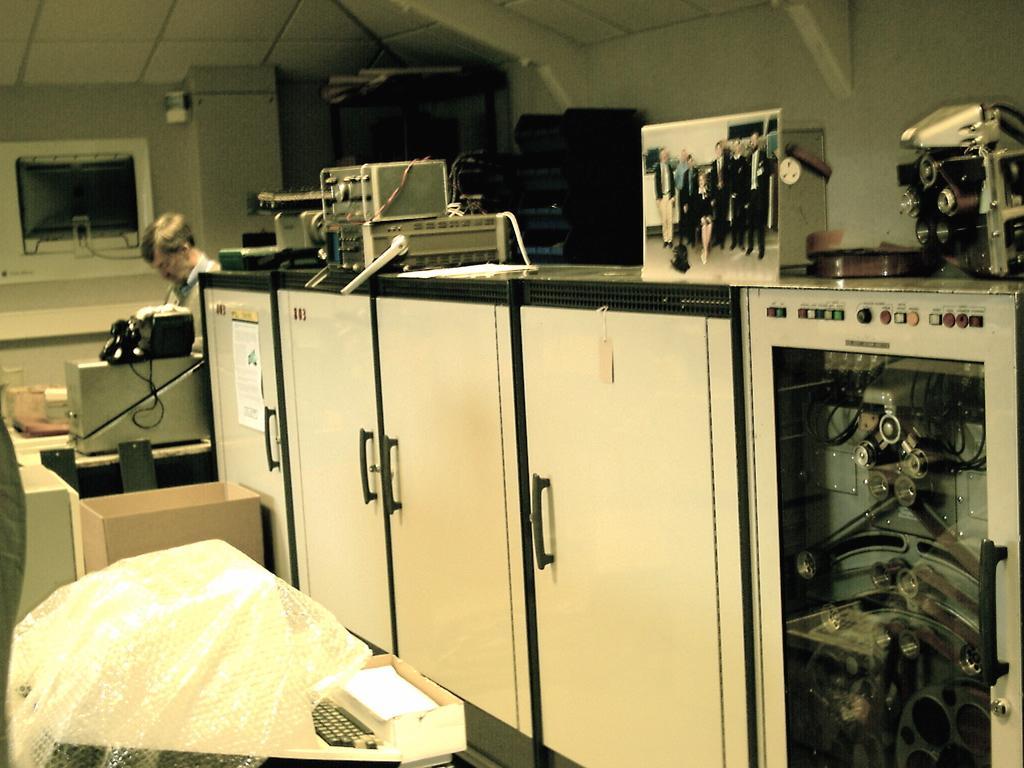Can you describe this image briefly? In the image we can see there is a person standing and there are electronic items kept on the table. There is a wardrobe. 